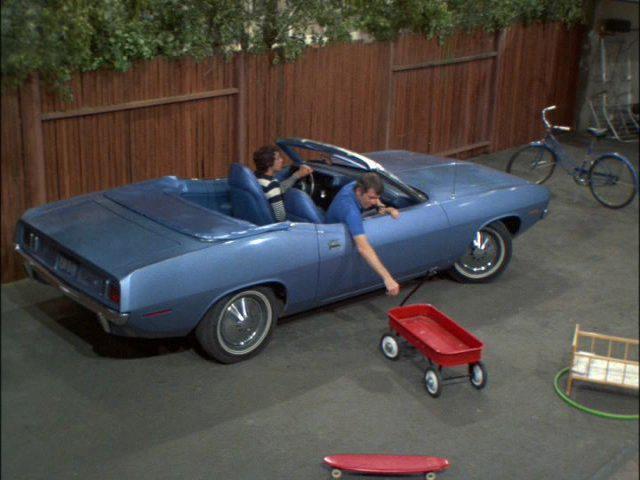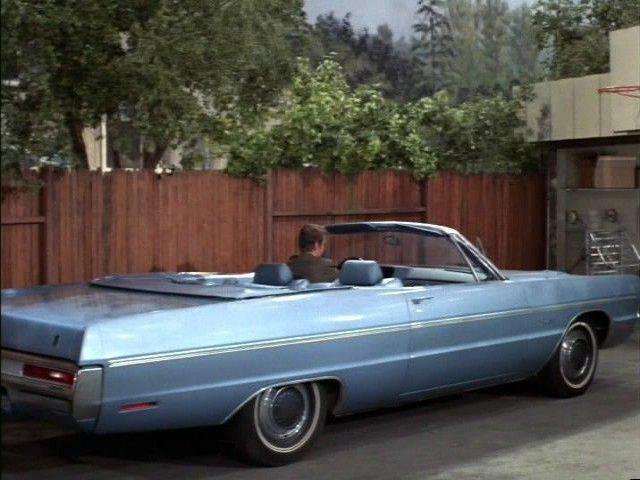The first image is the image on the left, the second image is the image on the right. Evaluate the accuracy of this statement regarding the images: "A young fellow bends and touches the front of a beat-up looking dark blue convertiblee.". Is it true? Answer yes or no. No. The first image is the image on the left, the second image is the image on the right. Analyze the images presented: Is the assertion "There is exactly one car in the right image that is parked beside a wooden fence." valid? Answer yes or no. Yes. 